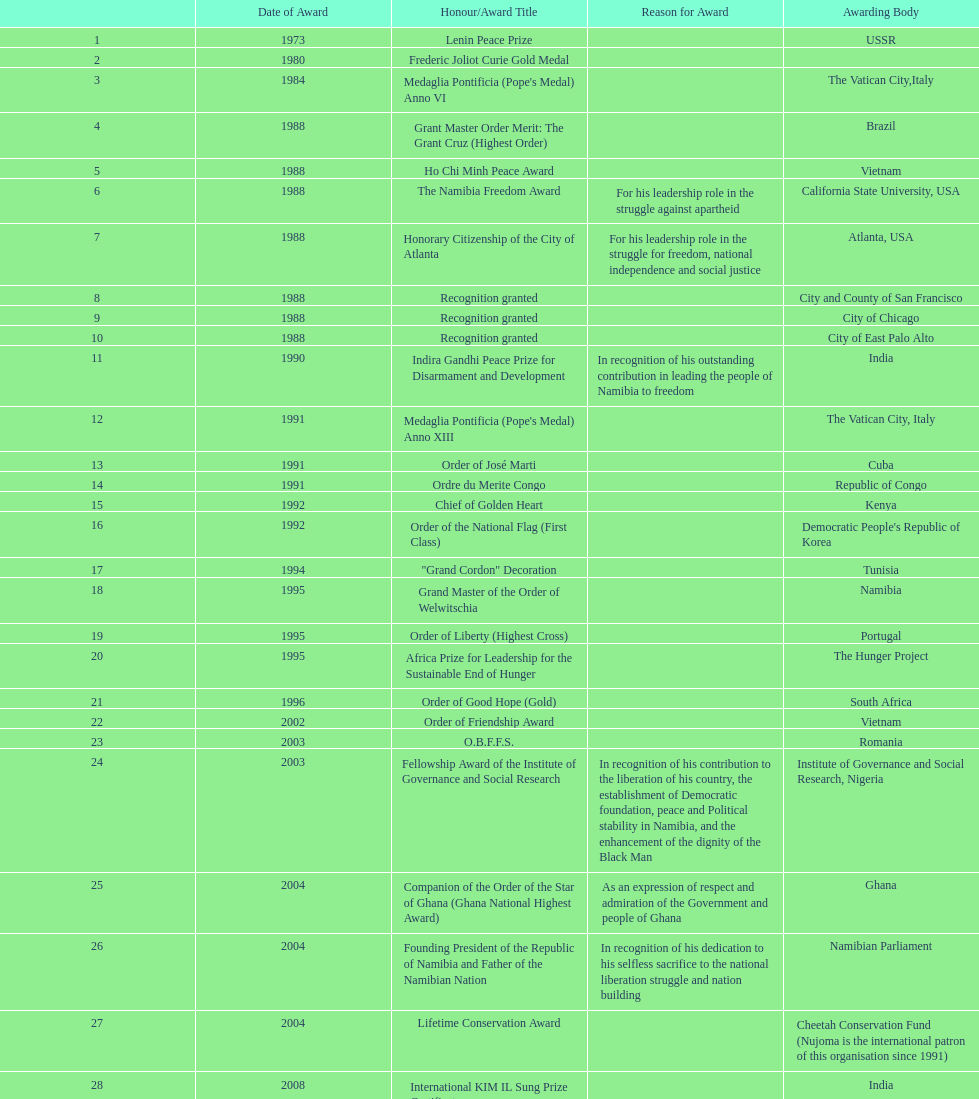What is the variation in the amount of awards achieved in 1988 compared to the amount of awards achieved in 1995? 4. 